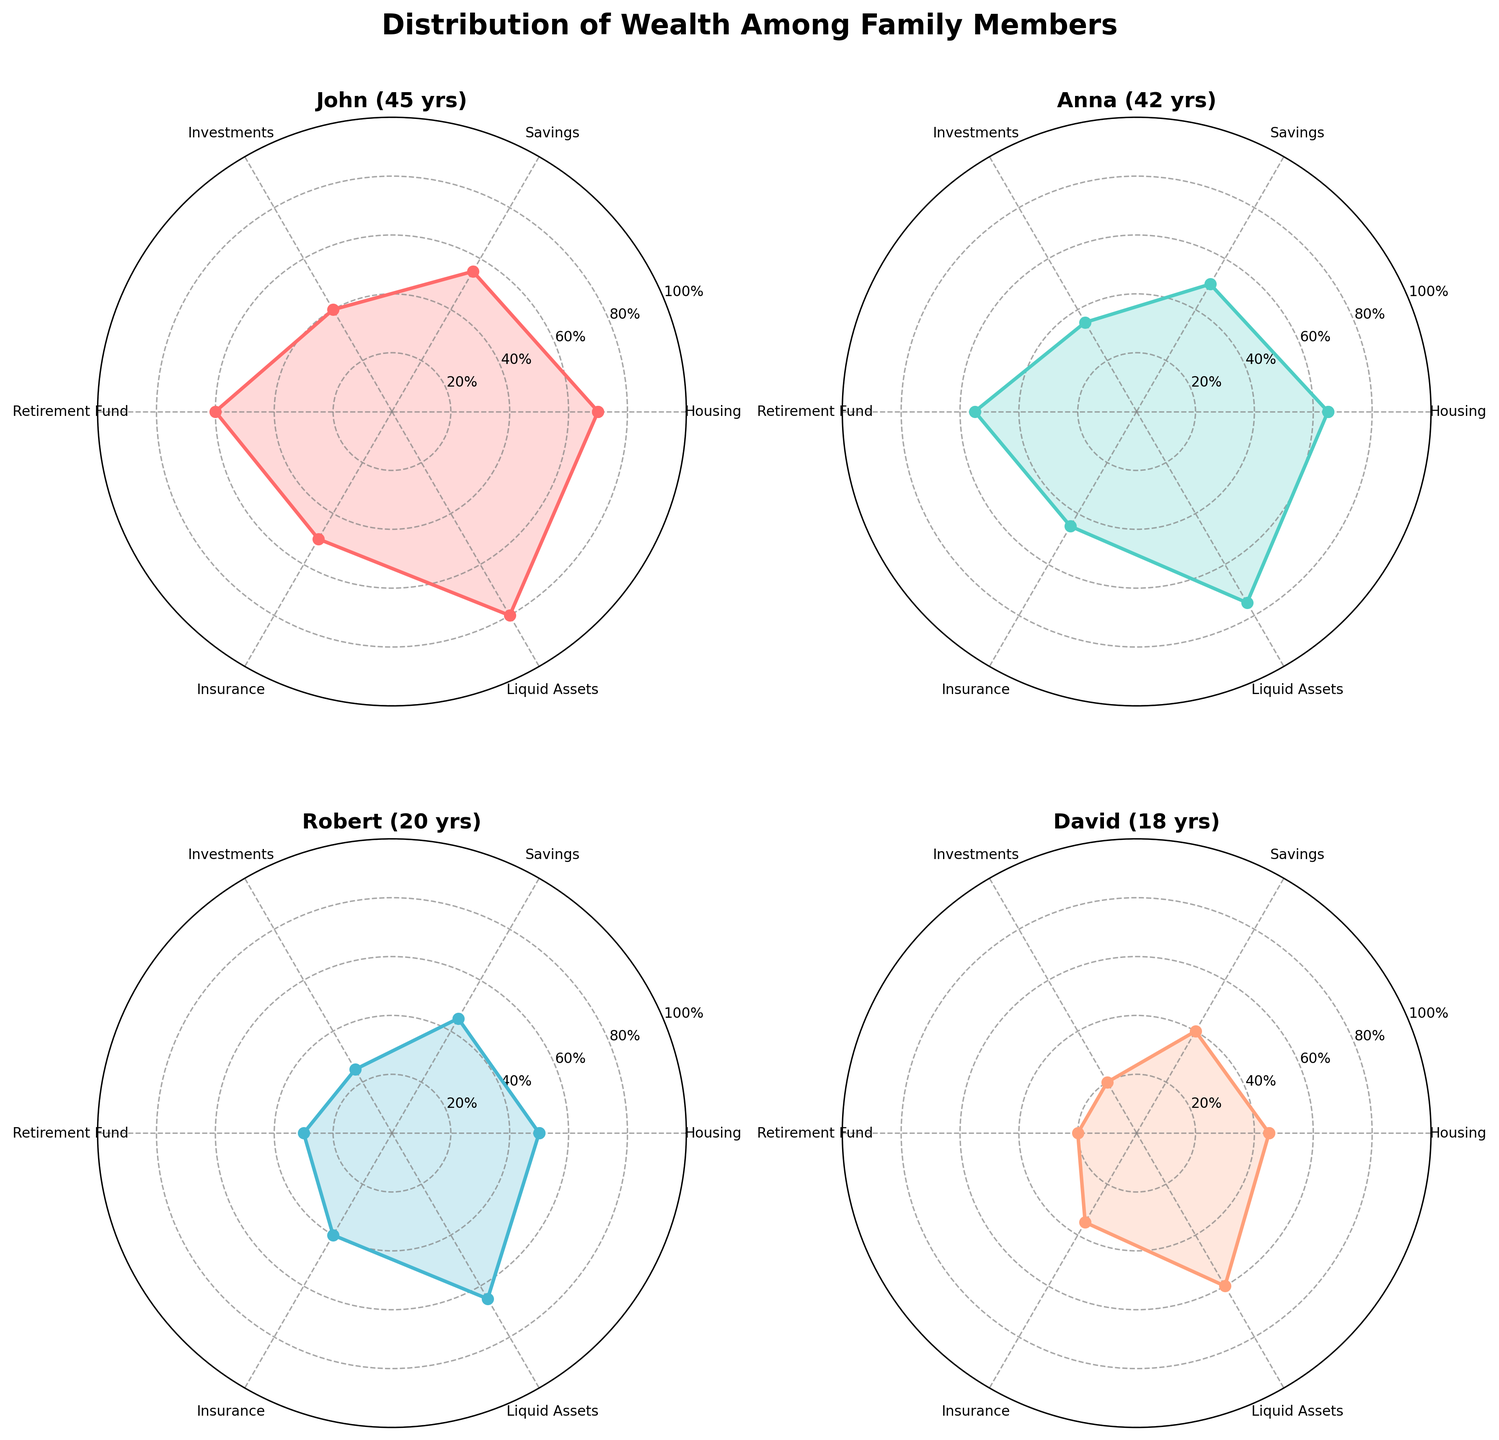What is the title of the figure? The title is located at the top of the figure and reads "Distribution of Wealth Among Family Members".
Answer: Distribution of Wealth Among Family Members Which family member has the highest value in Liquid Assets? On the radar chart for each individual, the segment for Liquid Assets extends furthest for John indicating the highest value.
Answer: John How many categories are used to visualize the distribution of wealth? Each subplot has a corresponding number of segments that indicate the categories. Counting these segments, we find there are six categories: Housing, Savings, Investments, Retirement Fund, Insurance, and Liquid Assets.
Answer: 6 Who has the lowest value in Investments? By examining the Investments segment in each subplot, we see that David's segment is the shortest in this category.
Answer: David Which individual has the highest overall average percentage across all categories? To find the individual with the highest overall average, we need to calculate the average of the values for each individual. John: (70+55+40+60+50+80)/6 = 59.17, Anna: (65+50+35+55+45+75)/6 = 54.17, Robert: (50+45+25+30+40+65)/6 = 42.5, David: (45+40+20+20+35+60)/6 = 36.67. John has the highest average.
Answer: John How does the Retirement Fund for Robert compare to that of David? The Retirement Fund value for Robert is 30 while for David it is 20. Comparing these values, Robert's is higher than David's.
Answer: Robert's is higher Which family member has the most balanced distribution across categories? The most balanced distribution means that individual has less fluctuation across different categories. Visual inspection shows that Anna's radar chart is more evenly distributed compared to others.
Answer: Anna What is the total combined value of Housing for all family members? Summing up the Housing values for all family members: John (70) + Anna (65) + Robert (50) + David (45) = 230.
Answer: 230 Which category shows the most significant discrepancy in values among family members? Large discrepancies appear where the radar sections differ the most. Visual inspection shows that the Investment category has a substantial range from 20 (David) to 40 (John).
Answer: Investments 